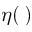Convert formula to latex. <formula><loc_0><loc_0><loc_500><loc_500>\eta ( \, )</formula> 